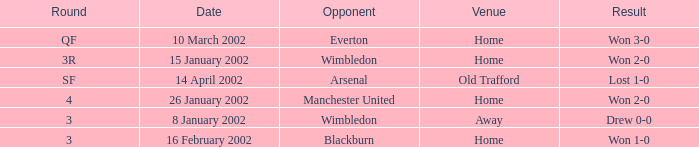I'm looking to parse the entire table for insights. Could you assist me with that? {'header': ['Round', 'Date', 'Opponent', 'Venue', 'Result'], 'rows': [['QF', '10 March 2002', 'Everton', 'Home', 'Won 3-0'], ['3R', '15 January 2002', 'Wimbledon', 'Home', 'Won 2-0'], ['SF', '14 April 2002', 'Arsenal', 'Old Trafford', 'Lost 1-0'], ['4', '26 January 2002', 'Manchester United', 'Home', 'Won 2-0'], ['3', '8 January 2002', 'Wimbledon', 'Away', 'Drew 0-0'], ['3', '16 February 2002', 'Blackburn', 'Home', 'Won 1-0']]} What is the Date with a Round with sf? 14 April 2002. 